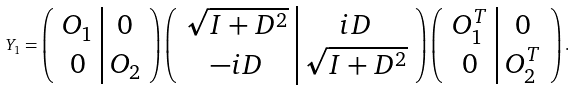Convert formula to latex. <formula><loc_0><loc_0><loc_500><loc_500>Y _ { 1 } = \left ( \begin{array} { c | c } O _ { 1 } & 0 \\ 0 & O _ { 2 } \end{array} \right ) \left ( \begin{array} { c | c } \sqrt { I + D ^ { 2 } } & i D \\ - i D & \sqrt { I + D ^ { 2 } } \end{array} \right ) \left ( \begin{array} { c | c } O ^ { T } _ { 1 } & 0 \\ 0 & O ^ { T } _ { 2 } \end{array} \right ) .</formula> 